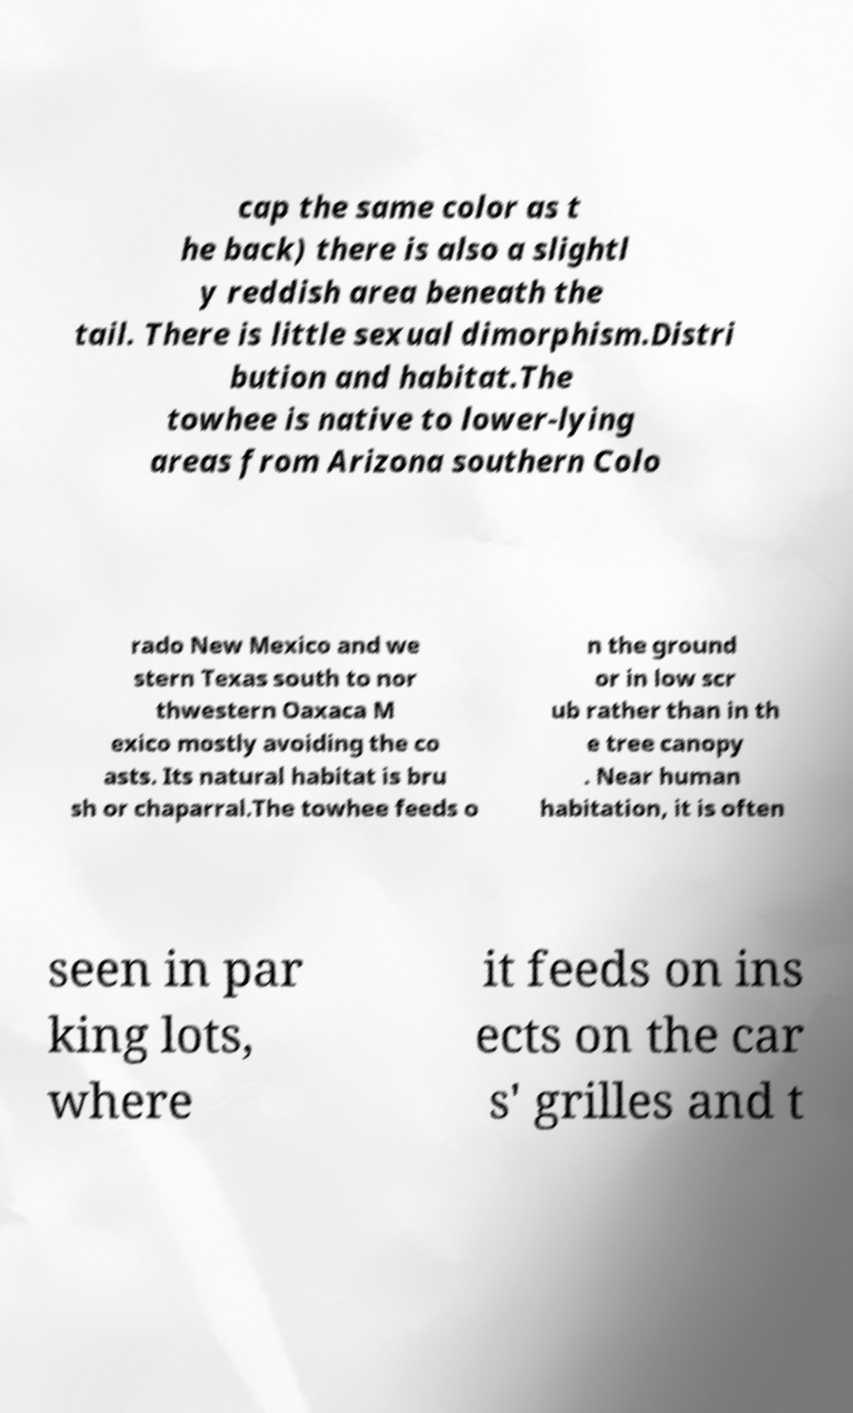Can you accurately transcribe the text from the provided image for me? cap the same color as t he back) there is also a slightl y reddish area beneath the tail. There is little sexual dimorphism.Distri bution and habitat.The towhee is native to lower-lying areas from Arizona southern Colo rado New Mexico and we stern Texas south to nor thwestern Oaxaca M exico mostly avoiding the co asts. Its natural habitat is bru sh or chaparral.The towhee feeds o n the ground or in low scr ub rather than in th e tree canopy . Near human habitation, it is often seen in par king lots, where it feeds on ins ects on the car s' grilles and t 